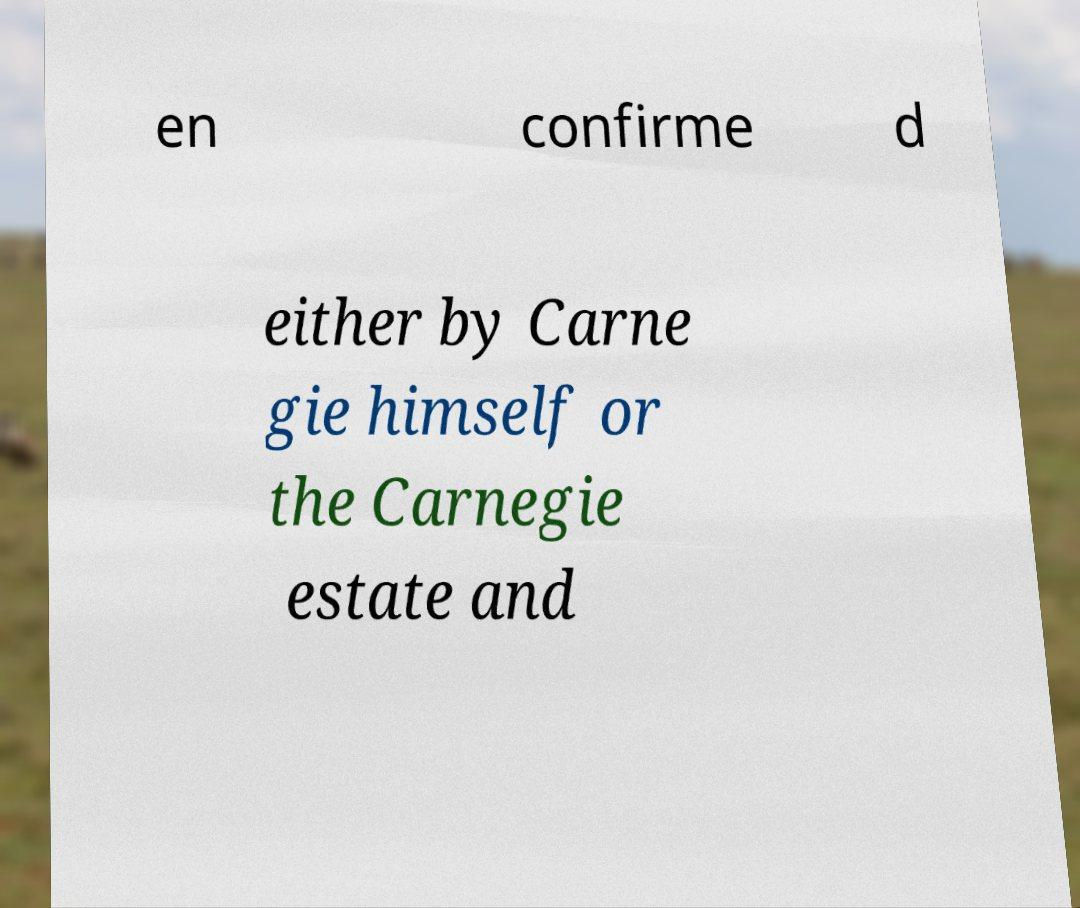There's text embedded in this image that I need extracted. Can you transcribe it verbatim? en confirme d either by Carne gie himself or the Carnegie estate and 